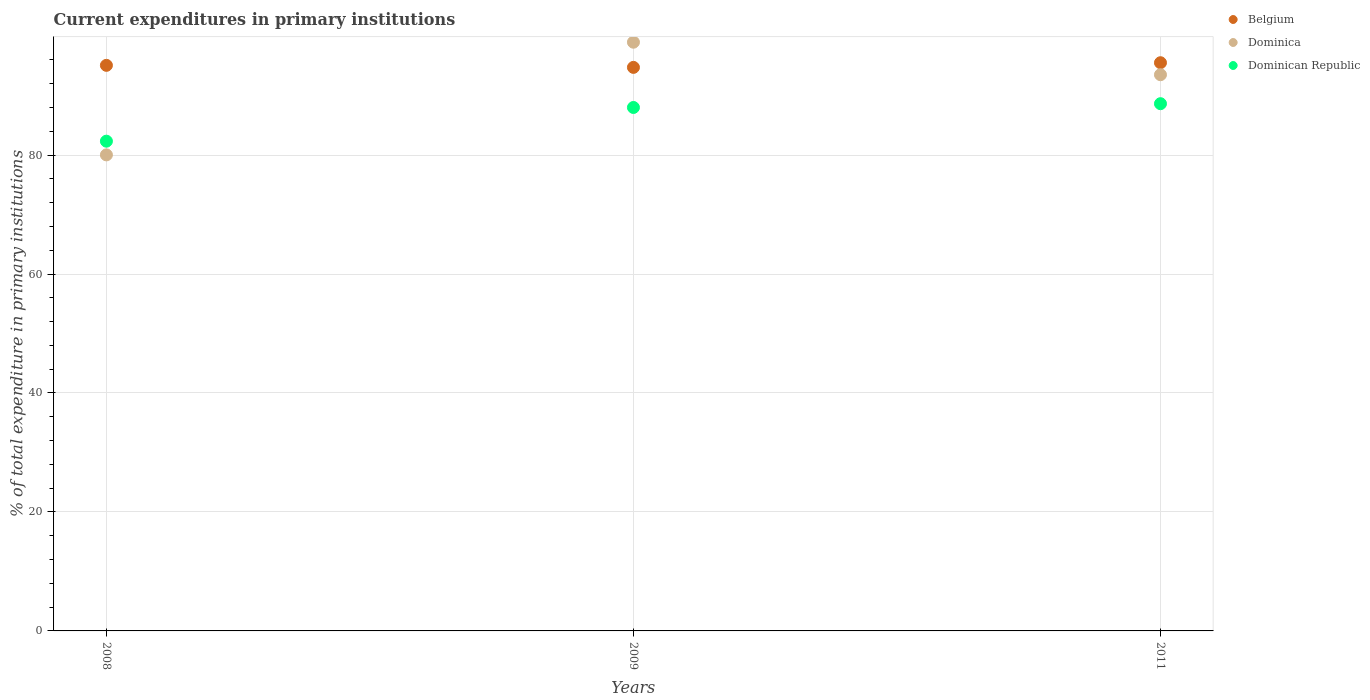How many different coloured dotlines are there?
Your response must be concise. 3. Is the number of dotlines equal to the number of legend labels?
Offer a terse response. Yes. What is the current expenditures in primary institutions in Dominica in 2011?
Your response must be concise. 93.5. Across all years, what is the maximum current expenditures in primary institutions in Dominica?
Keep it short and to the point. 98.97. Across all years, what is the minimum current expenditures in primary institutions in Belgium?
Your answer should be very brief. 94.74. In which year was the current expenditures in primary institutions in Dominica minimum?
Your answer should be very brief. 2008. What is the total current expenditures in primary institutions in Dominican Republic in the graph?
Your answer should be compact. 258.97. What is the difference between the current expenditures in primary institutions in Belgium in 2008 and that in 2009?
Keep it short and to the point. 0.34. What is the difference between the current expenditures in primary institutions in Dominica in 2011 and the current expenditures in primary institutions in Dominican Republic in 2009?
Make the answer very short. 5.51. What is the average current expenditures in primary institutions in Dominica per year?
Make the answer very short. 90.83. In the year 2008, what is the difference between the current expenditures in primary institutions in Dominica and current expenditures in primary institutions in Dominican Republic?
Offer a very short reply. -2.3. What is the ratio of the current expenditures in primary institutions in Belgium in 2009 to that in 2011?
Provide a short and direct response. 0.99. Is the current expenditures in primary institutions in Belgium in 2008 less than that in 2011?
Your response must be concise. Yes. What is the difference between the highest and the second highest current expenditures in primary institutions in Dominican Republic?
Make the answer very short. 0.64. What is the difference between the highest and the lowest current expenditures in primary institutions in Dominica?
Your response must be concise. 18.94. Is the sum of the current expenditures in primary institutions in Belgium in 2009 and 2011 greater than the maximum current expenditures in primary institutions in Dominica across all years?
Your answer should be compact. Yes. Does the current expenditures in primary institutions in Dominica monotonically increase over the years?
Your response must be concise. No. Is the current expenditures in primary institutions in Dominican Republic strictly less than the current expenditures in primary institutions in Belgium over the years?
Offer a very short reply. Yes. How many dotlines are there?
Your answer should be very brief. 3. How many years are there in the graph?
Keep it short and to the point. 3. Are the values on the major ticks of Y-axis written in scientific E-notation?
Make the answer very short. No. Does the graph contain any zero values?
Keep it short and to the point. No. Does the graph contain grids?
Your response must be concise. Yes. How are the legend labels stacked?
Provide a short and direct response. Vertical. What is the title of the graph?
Your answer should be compact. Current expenditures in primary institutions. Does "Turkmenistan" appear as one of the legend labels in the graph?
Keep it short and to the point. No. What is the label or title of the Y-axis?
Ensure brevity in your answer.  % of total expenditure in primary institutions. What is the % of total expenditure in primary institutions in Belgium in 2008?
Your answer should be very brief. 95.08. What is the % of total expenditure in primary institutions of Dominica in 2008?
Your answer should be compact. 80.03. What is the % of total expenditure in primary institutions of Dominican Republic in 2008?
Provide a short and direct response. 82.33. What is the % of total expenditure in primary institutions in Belgium in 2009?
Offer a very short reply. 94.74. What is the % of total expenditure in primary institutions in Dominica in 2009?
Offer a terse response. 98.97. What is the % of total expenditure in primary institutions of Dominican Republic in 2009?
Your response must be concise. 88. What is the % of total expenditure in primary institutions in Belgium in 2011?
Provide a succinct answer. 95.52. What is the % of total expenditure in primary institutions of Dominica in 2011?
Offer a terse response. 93.5. What is the % of total expenditure in primary institutions of Dominican Republic in 2011?
Ensure brevity in your answer.  88.63. Across all years, what is the maximum % of total expenditure in primary institutions of Belgium?
Provide a succinct answer. 95.52. Across all years, what is the maximum % of total expenditure in primary institutions in Dominica?
Your response must be concise. 98.97. Across all years, what is the maximum % of total expenditure in primary institutions in Dominican Republic?
Offer a terse response. 88.63. Across all years, what is the minimum % of total expenditure in primary institutions in Belgium?
Make the answer very short. 94.74. Across all years, what is the minimum % of total expenditure in primary institutions in Dominica?
Your answer should be compact. 80.03. Across all years, what is the minimum % of total expenditure in primary institutions in Dominican Republic?
Provide a succinct answer. 82.33. What is the total % of total expenditure in primary institutions of Belgium in the graph?
Ensure brevity in your answer.  285.34. What is the total % of total expenditure in primary institutions of Dominica in the graph?
Keep it short and to the point. 272.5. What is the total % of total expenditure in primary institutions in Dominican Republic in the graph?
Your response must be concise. 258.97. What is the difference between the % of total expenditure in primary institutions in Belgium in 2008 and that in 2009?
Ensure brevity in your answer.  0.34. What is the difference between the % of total expenditure in primary institutions of Dominica in 2008 and that in 2009?
Give a very brief answer. -18.94. What is the difference between the % of total expenditure in primary institutions of Dominican Republic in 2008 and that in 2009?
Your answer should be very brief. -5.67. What is the difference between the % of total expenditure in primary institutions in Belgium in 2008 and that in 2011?
Keep it short and to the point. -0.44. What is the difference between the % of total expenditure in primary institutions of Dominica in 2008 and that in 2011?
Provide a succinct answer. -13.48. What is the difference between the % of total expenditure in primary institutions in Dominican Republic in 2008 and that in 2011?
Make the answer very short. -6.3. What is the difference between the % of total expenditure in primary institutions in Belgium in 2009 and that in 2011?
Make the answer very short. -0.78. What is the difference between the % of total expenditure in primary institutions in Dominica in 2009 and that in 2011?
Make the answer very short. 5.47. What is the difference between the % of total expenditure in primary institutions in Dominican Republic in 2009 and that in 2011?
Your answer should be compact. -0.64. What is the difference between the % of total expenditure in primary institutions in Belgium in 2008 and the % of total expenditure in primary institutions in Dominica in 2009?
Your answer should be very brief. -3.89. What is the difference between the % of total expenditure in primary institutions in Belgium in 2008 and the % of total expenditure in primary institutions in Dominican Republic in 2009?
Ensure brevity in your answer.  7.08. What is the difference between the % of total expenditure in primary institutions in Dominica in 2008 and the % of total expenditure in primary institutions in Dominican Republic in 2009?
Your answer should be very brief. -7.97. What is the difference between the % of total expenditure in primary institutions of Belgium in 2008 and the % of total expenditure in primary institutions of Dominica in 2011?
Offer a terse response. 1.58. What is the difference between the % of total expenditure in primary institutions of Belgium in 2008 and the % of total expenditure in primary institutions of Dominican Republic in 2011?
Your answer should be compact. 6.45. What is the difference between the % of total expenditure in primary institutions in Dominica in 2008 and the % of total expenditure in primary institutions in Dominican Republic in 2011?
Your answer should be very brief. -8.61. What is the difference between the % of total expenditure in primary institutions of Belgium in 2009 and the % of total expenditure in primary institutions of Dominica in 2011?
Keep it short and to the point. 1.23. What is the difference between the % of total expenditure in primary institutions in Belgium in 2009 and the % of total expenditure in primary institutions in Dominican Republic in 2011?
Ensure brevity in your answer.  6.1. What is the difference between the % of total expenditure in primary institutions in Dominica in 2009 and the % of total expenditure in primary institutions in Dominican Republic in 2011?
Offer a terse response. 10.34. What is the average % of total expenditure in primary institutions in Belgium per year?
Your answer should be very brief. 95.11. What is the average % of total expenditure in primary institutions in Dominica per year?
Make the answer very short. 90.83. What is the average % of total expenditure in primary institutions of Dominican Republic per year?
Provide a short and direct response. 86.32. In the year 2008, what is the difference between the % of total expenditure in primary institutions of Belgium and % of total expenditure in primary institutions of Dominica?
Offer a terse response. 15.05. In the year 2008, what is the difference between the % of total expenditure in primary institutions in Belgium and % of total expenditure in primary institutions in Dominican Republic?
Give a very brief answer. 12.75. In the year 2008, what is the difference between the % of total expenditure in primary institutions in Dominica and % of total expenditure in primary institutions in Dominican Republic?
Ensure brevity in your answer.  -2.3. In the year 2009, what is the difference between the % of total expenditure in primary institutions in Belgium and % of total expenditure in primary institutions in Dominica?
Your answer should be compact. -4.23. In the year 2009, what is the difference between the % of total expenditure in primary institutions of Belgium and % of total expenditure in primary institutions of Dominican Republic?
Keep it short and to the point. 6.74. In the year 2009, what is the difference between the % of total expenditure in primary institutions in Dominica and % of total expenditure in primary institutions in Dominican Republic?
Keep it short and to the point. 10.97. In the year 2011, what is the difference between the % of total expenditure in primary institutions of Belgium and % of total expenditure in primary institutions of Dominica?
Offer a very short reply. 2.02. In the year 2011, what is the difference between the % of total expenditure in primary institutions of Belgium and % of total expenditure in primary institutions of Dominican Republic?
Offer a very short reply. 6.89. In the year 2011, what is the difference between the % of total expenditure in primary institutions of Dominica and % of total expenditure in primary institutions of Dominican Republic?
Your answer should be very brief. 4.87. What is the ratio of the % of total expenditure in primary institutions of Dominica in 2008 to that in 2009?
Give a very brief answer. 0.81. What is the ratio of the % of total expenditure in primary institutions of Dominican Republic in 2008 to that in 2009?
Give a very brief answer. 0.94. What is the ratio of the % of total expenditure in primary institutions of Belgium in 2008 to that in 2011?
Make the answer very short. 1. What is the ratio of the % of total expenditure in primary institutions in Dominica in 2008 to that in 2011?
Offer a terse response. 0.86. What is the ratio of the % of total expenditure in primary institutions of Dominican Republic in 2008 to that in 2011?
Give a very brief answer. 0.93. What is the ratio of the % of total expenditure in primary institutions of Belgium in 2009 to that in 2011?
Keep it short and to the point. 0.99. What is the ratio of the % of total expenditure in primary institutions in Dominica in 2009 to that in 2011?
Your response must be concise. 1.06. What is the ratio of the % of total expenditure in primary institutions of Dominican Republic in 2009 to that in 2011?
Offer a terse response. 0.99. What is the difference between the highest and the second highest % of total expenditure in primary institutions of Belgium?
Offer a very short reply. 0.44. What is the difference between the highest and the second highest % of total expenditure in primary institutions in Dominica?
Offer a terse response. 5.47. What is the difference between the highest and the second highest % of total expenditure in primary institutions in Dominican Republic?
Ensure brevity in your answer.  0.64. What is the difference between the highest and the lowest % of total expenditure in primary institutions in Belgium?
Make the answer very short. 0.78. What is the difference between the highest and the lowest % of total expenditure in primary institutions of Dominica?
Your answer should be very brief. 18.94. What is the difference between the highest and the lowest % of total expenditure in primary institutions in Dominican Republic?
Provide a succinct answer. 6.3. 